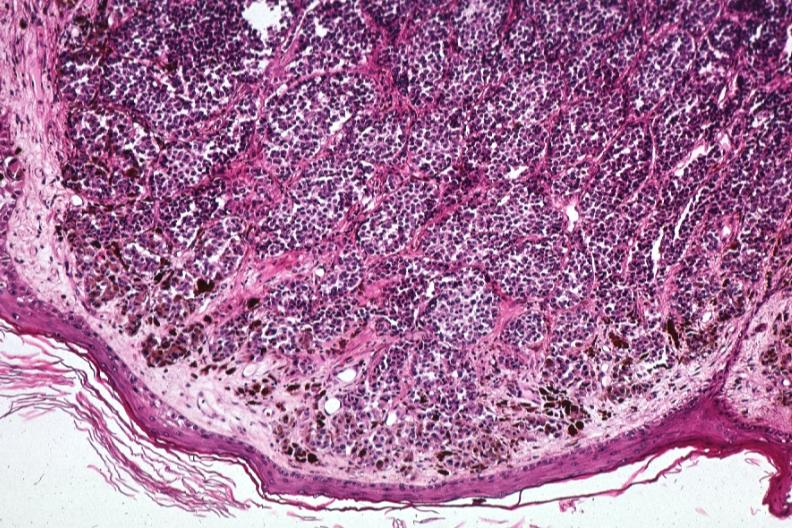does chloramphenicol toxicity show low excellent depiction of lesion that probably is metastatic slides 1 are same lesion?
Answer the question using a single word or phrase. No 